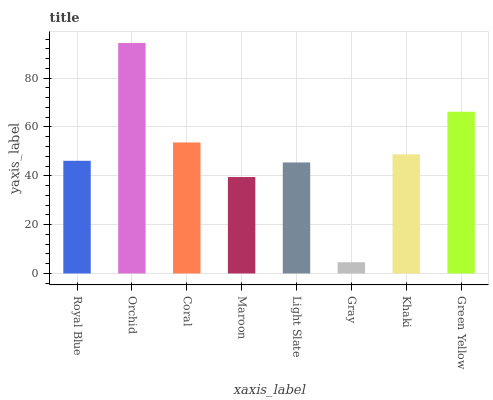Is Coral the minimum?
Answer yes or no. No. Is Coral the maximum?
Answer yes or no. No. Is Orchid greater than Coral?
Answer yes or no. Yes. Is Coral less than Orchid?
Answer yes or no. Yes. Is Coral greater than Orchid?
Answer yes or no. No. Is Orchid less than Coral?
Answer yes or no. No. Is Khaki the high median?
Answer yes or no. Yes. Is Royal Blue the low median?
Answer yes or no. Yes. Is Maroon the high median?
Answer yes or no. No. Is Light Slate the low median?
Answer yes or no. No. 